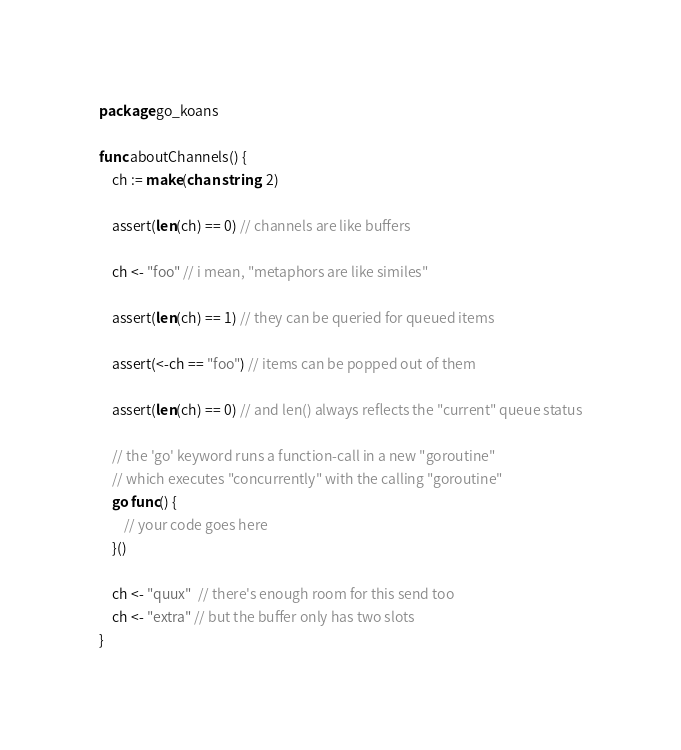<code> <loc_0><loc_0><loc_500><loc_500><_Go_>package go_koans

func aboutChannels() {
	ch := make(chan string, 2)

	assert(len(ch) == 0) // channels are like buffers

	ch <- "foo" // i mean, "metaphors are like similes"

	assert(len(ch) == 1) // they can be queried for queued items

	assert(<-ch == "foo") // items can be popped out of them

	assert(len(ch) == 0) // and len() always reflects the "current" queue status

	// the 'go' keyword runs a function-call in a new "goroutine"
	// which executes "concurrently" with the calling "goroutine"
	go func() {
		// your code goes here
	}()

	ch <- "quux"  // there's enough room for this send too
	ch <- "extra" // but the buffer only has two slots
}
</code> 